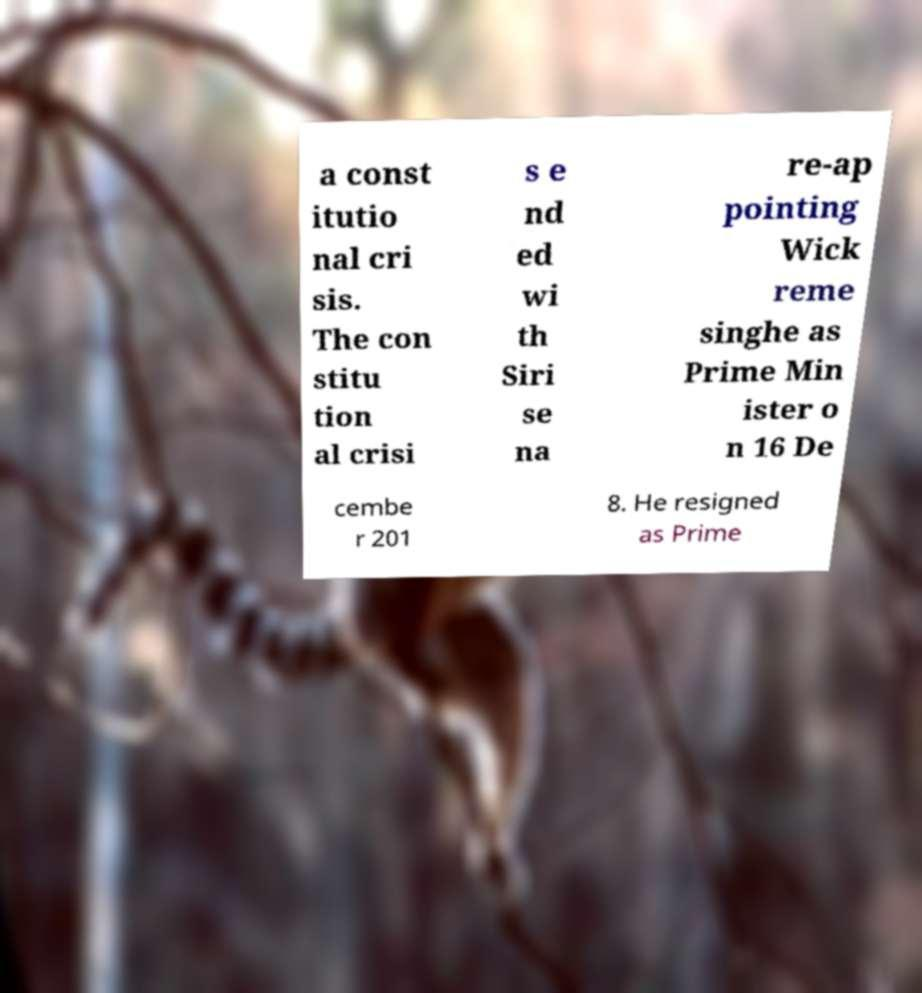Can you read and provide the text displayed in the image?This photo seems to have some interesting text. Can you extract and type it out for me? a const itutio nal cri sis. The con stitu tion al crisi s e nd ed wi th Siri se na re-ap pointing Wick reme singhe as Prime Min ister o n 16 De cembe r 201 8. He resigned as Prime 